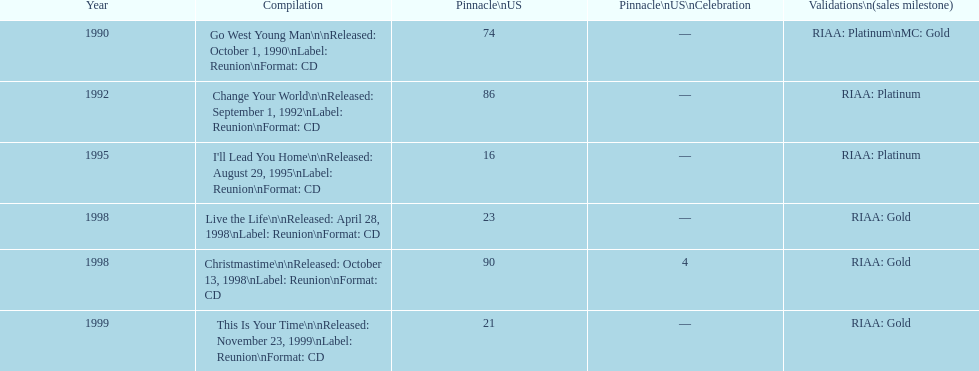What is the number of michael w smith albums that made it to the top 25 of the charts? 3. 